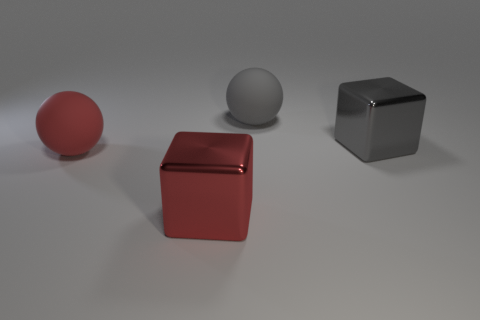Are there any large rubber balls behind the gray metal block?
Provide a short and direct response. Yes. What is the color of the other sphere that is the same size as the gray sphere?
Your answer should be compact. Red. What number of objects have the same material as the large gray sphere?
Provide a succinct answer. 1. What number of other objects are there of the same size as the gray cube?
Offer a terse response. 3. Is there a matte ball of the same size as the gray shiny object?
Your answer should be very brief. Yes. How many things are red shiny things or gray cubes?
Provide a succinct answer. 2. Does the metallic thing that is right of the red metallic thing have the same size as the red metallic cube?
Your answer should be very brief. Yes. How big is the thing that is in front of the gray matte ball and behind the large red ball?
Ensure brevity in your answer.  Large. What number of other things are there of the same shape as the red rubber object?
Offer a terse response. 1. How many other things are the same material as the big gray ball?
Provide a short and direct response. 1. 